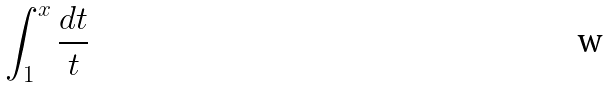Convert formula to latex. <formula><loc_0><loc_0><loc_500><loc_500>\int _ { 1 } ^ { x } \frac { d t } { t }</formula> 